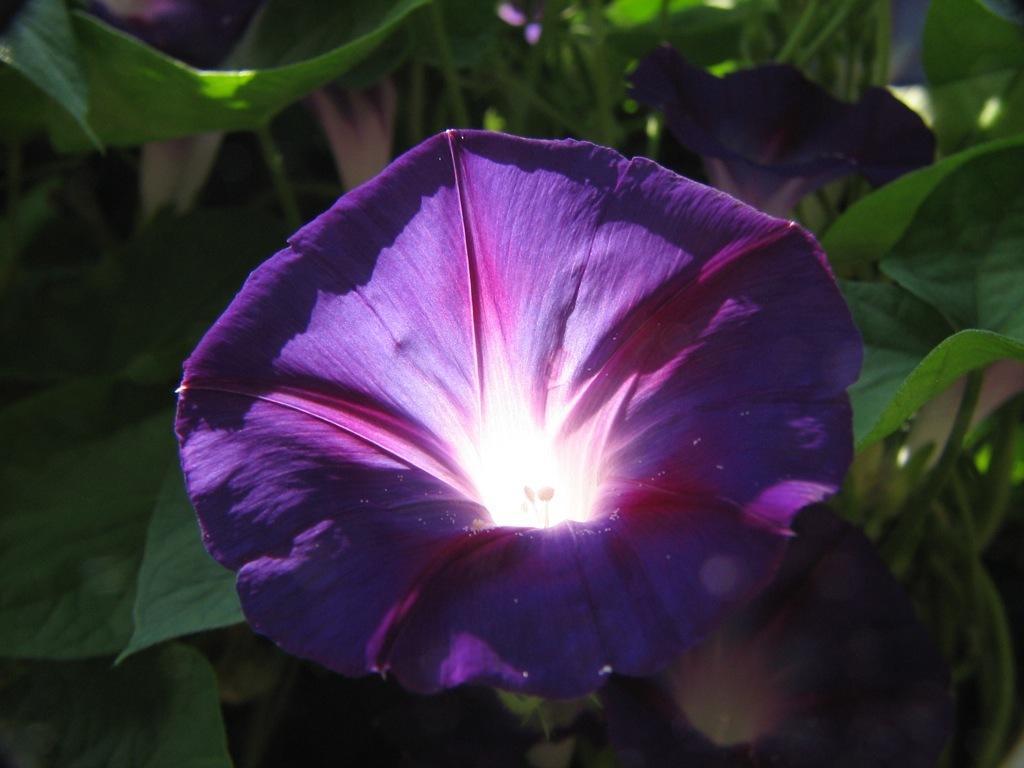In one or two sentences, can you explain what this image depicts? In this picture we can see flowers and leaves. 